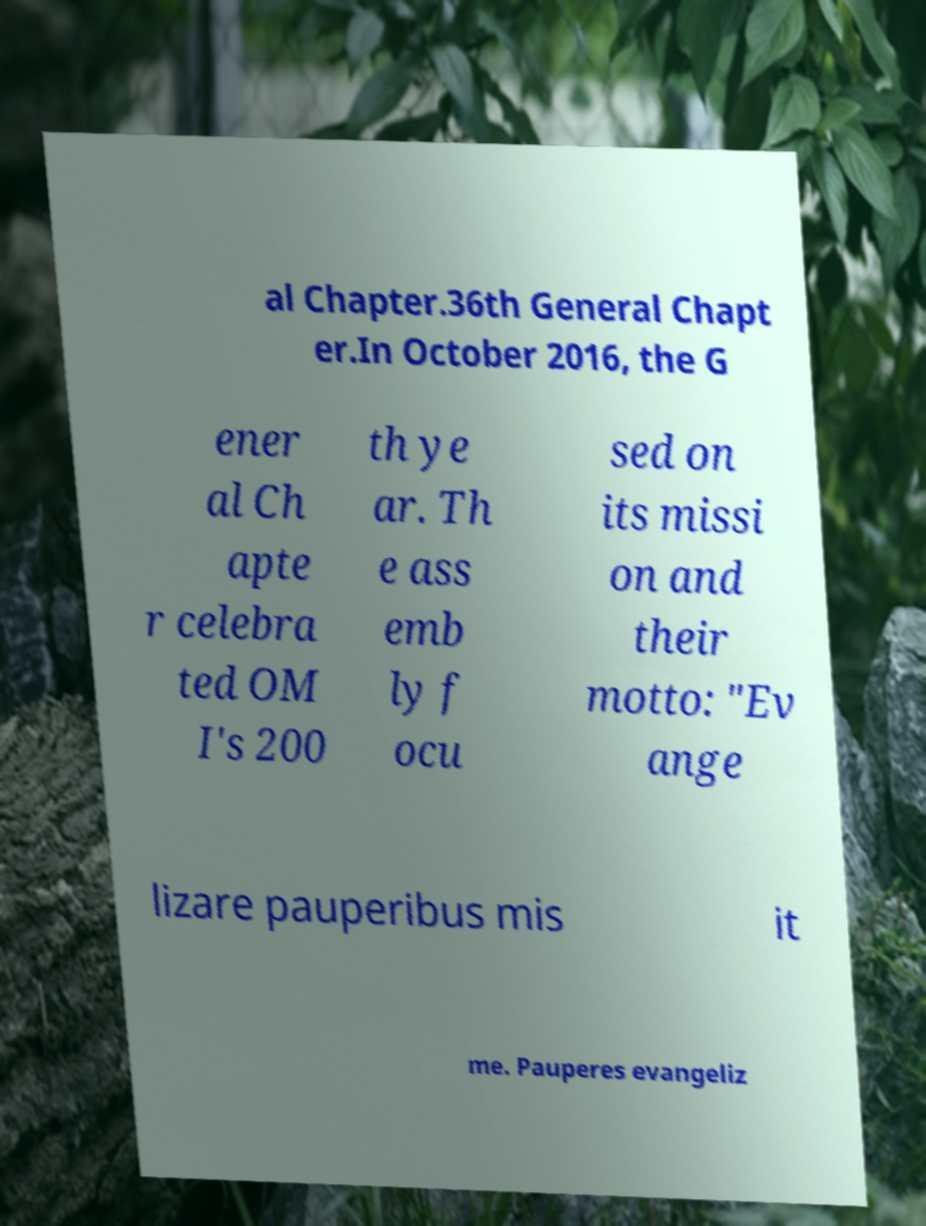There's text embedded in this image that I need extracted. Can you transcribe it verbatim? al Chapter.36th General Chapt er.In October 2016, the G ener al Ch apte r celebra ted OM I's 200 th ye ar. Th e ass emb ly f ocu sed on its missi on and their motto: "Ev ange lizare pauperibus mis it me. Pauperes evangeliz 